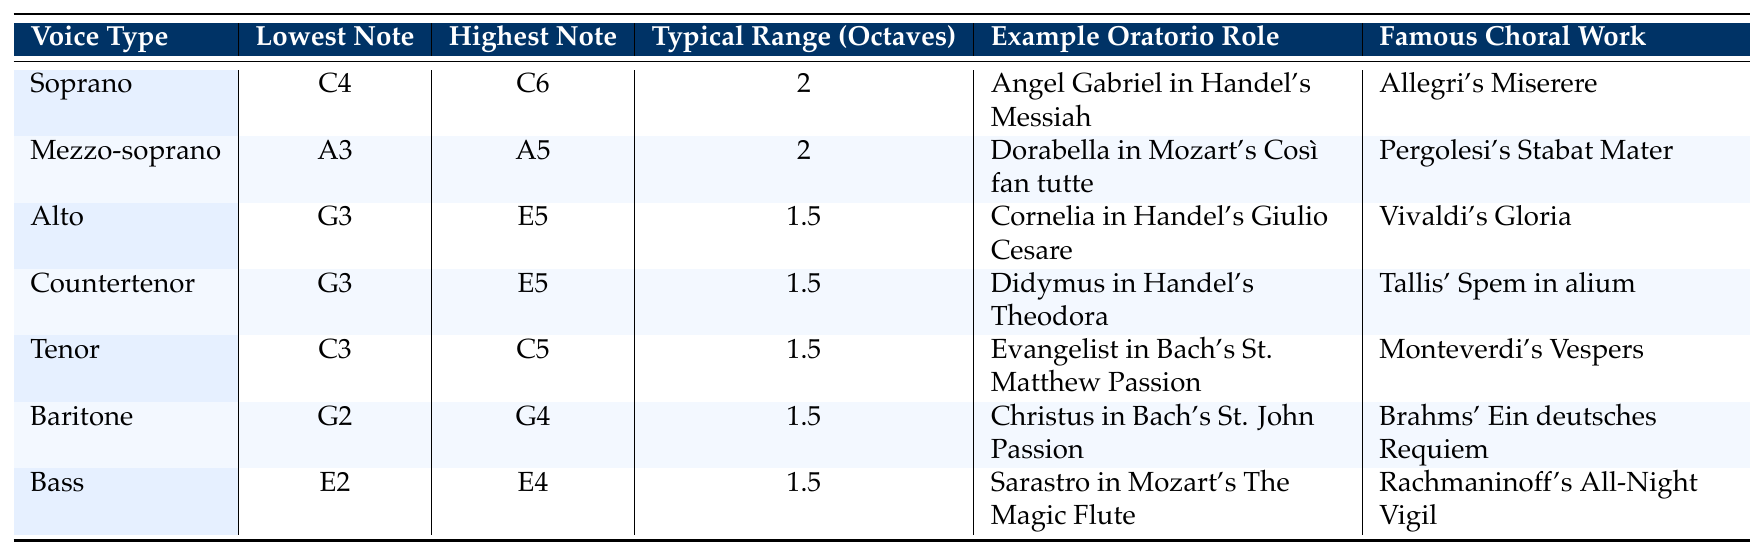What is the lowest note for a Soprano? The table lists the lowest note for Soprano as C4.
Answer: C4 Which voice type has the highest note of A5? From the table, the Mezzo-soprano is the only voice type listed with the highest note of A5.
Answer: Mezzo-soprano How many octaves is the typical range for Alto singers? The table indicates that Alto singers typically have a range of 1.5 octaves.
Answer: 1.5 Is the lowest note for Tenor lower than that for Baritone? The lowest note for Tenor is C3 and for Baritone is G2. Since C3 is higher than G2, the answer is no.
Answer: No Which voice type typically spans the largest vocal range in octaves? Both Soprano and Mezzo-soprano have a typical range of 2 octaves, which is the largest range listed.
Answer: Soprano and Mezzo-soprano What is the difference in lowest notes between Bass and Alto? The lowest note for Bass is E2 and for Alto is G3. To find the difference in semitones, we count: G3 (G): 1-2-3-4-5-6-7-8-9-10-11-12 (C4) down to E2 = 12 semitones (1 octave) + 2 semitones (to E2) = 14 semitones.
Answer: 14 semitones Can you name a famous choral work associated with the Baritone voice type? The table lists Brahms' Ein deutsches Requiem as a famous choral work associated with Baritone.
Answer: Brahms' Ein deutsches Requiem Which has a smaller typical range: Countertenor or Bass? Both Countertenor and Bass have a typical range of 1.5 octaves. Therefore, they do not differ in size.
Answer: They are equal How many voice types have a typical range of 1.5 octaves? The table shows that four voice types (Alto, Countertenor, Tenor, Baritone, and Bass) have a typical range of 1.5 octaves.
Answer: Four What is the highest note for the Bass voice type? According to the table, the highest note for the Bass voice type is E4.
Answer: E4 What role does a Soprano typically perform in oratorios? The table states that a Soprano typically performs as the Angel Gabriel in Handel's Messiah.
Answer: Angel Gabriel in Handel's Messiah What is the typical range in octaves for Mezzo-soprano? The table indicates that the typical range for Mezzo-soprano is 2 octaves.
Answer: 2 